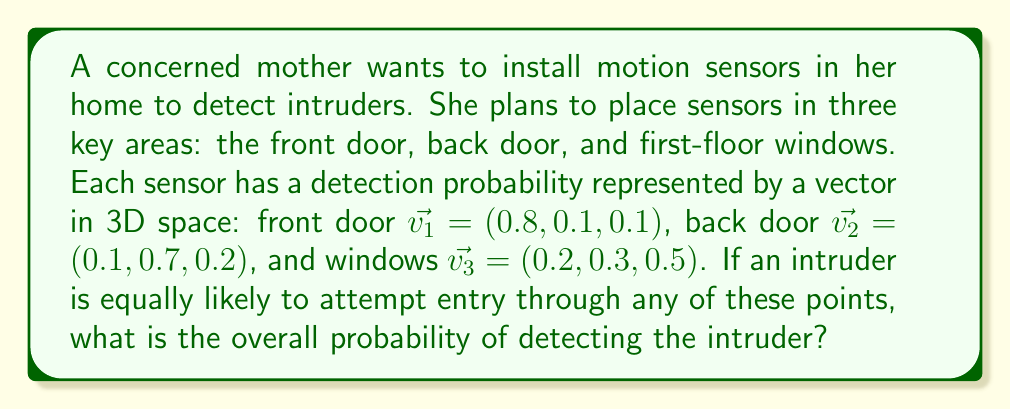Provide a solution to this math problem. To solve this problem, we'll use concepts from vector spaces and probability theory:

1) First, we need to understand what the vectors represent. Each vector component corresponds to the probability of detection for a specific entry point (front door, back door, windows).

2) Since the intruder is equally likely to attempt entry through any point, we can represent this with a uniform probability vector:
   $$\vec{p} = (\frac{1}{3}, \frac{1}{3}, \frac{1}{3})$$

3) To find the overall detection probability, we need to calculate the dot product of this probability vector with the sum of our sensor vectors:
   $$P(\text{detection}) = \vec{p} \cdot (\vec{v_1} + \vec{v_2} + \vec{v_3})$$

4) Let's sum the sensor vectors:
   $$\vec{v_1} + \vec{v_2} + \vec{v_3} = (0.8, 0.1, 0.1) + (0.1, 0.7, 0.2) + (0.2, 0.3, 0.5)$$
   $$= (1.1, 1.1, 0.8)$$

5) Now, let's calculate the dot product:
   $$P(\text{detection}) = (\frac{1}{3}, \frac{1}{3}, \frac{1}{3}) \cdot (1.1, 1.1, 0.8)$$
   $$= \frac{1}{3}(1.1) + \frac{1}{3}(1.1) + \frac{1}{3}(0.8)$$
   $$= 0.3667 + 0.3667 + 0.2667$$
   $$= 1$$

6) Therefore, the overall probability of detecting the intruder is 1, or 100%.
Answer: $1$ (or $100\%$) 